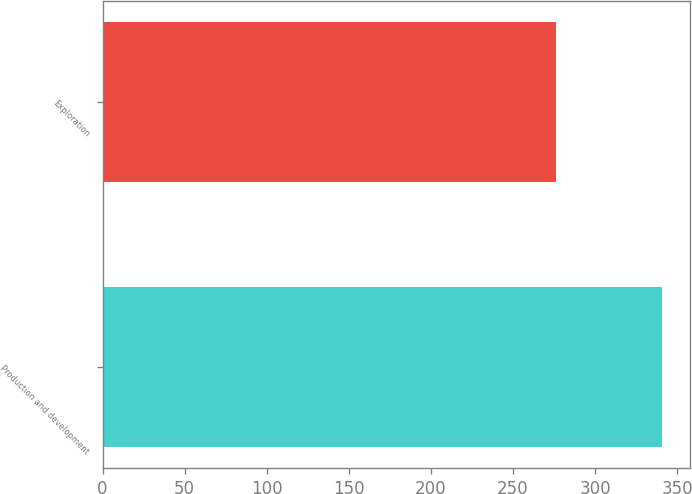Convert chart to OTSL. <chart><loc_0><loc_0><loc_500><loc_500><bar_chart><fcel>Production and development<fcel>Exploration<nl><fcel>341<fcel>276<nl></chart> 